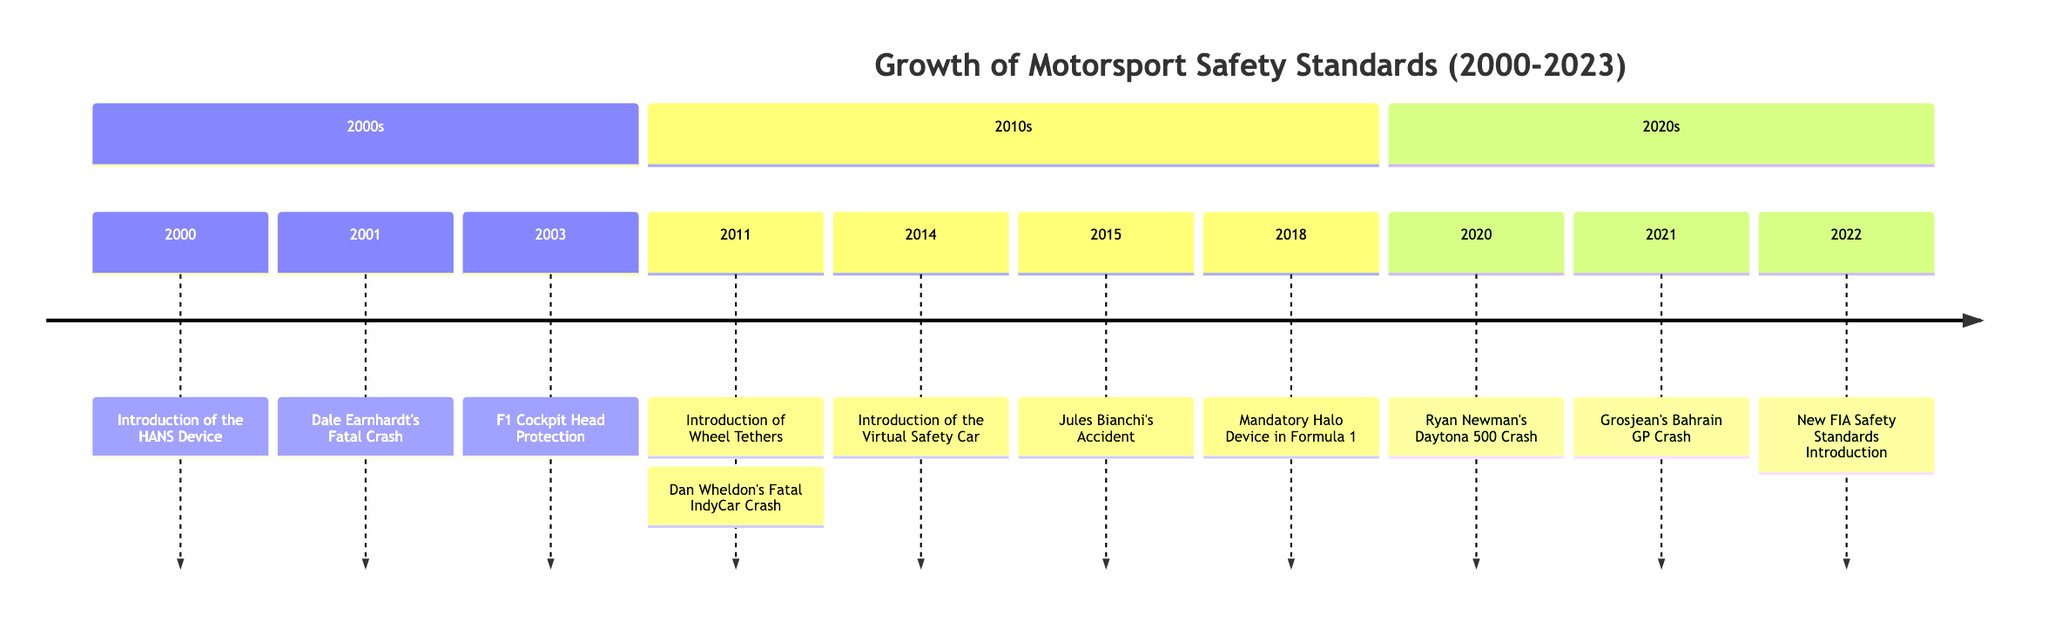What year did the HANS device become mandatory? The HANS device was introduced in 2000, which makes that the year it became mandatory in various motorsport disciplines.
Answer: 2000 How many major incidents are listed in the timeline? By counting the significant incidents mentioned in the timeline, we find six occurrences: Dale Earnhardt's crash in 2001, Dan Wheldon's crash in 2011, Jules Bianchi's accident in 2015, Ryan Newman's crash in 2020, and Grosjean's crash in 2021.
Answer: 6 What safety feature was introduced in Formula 1 in 2018? The Halo device became mandatory in Formula 1 and Formula 2 to enhance head protection for drivers.
Answer: Halo device What significant event influenced the introduction of the Virtual Safety Car? The Virtual Safety Car was introduced in 2014, primarily to improve safety during incidents in response to the need to slow down cars without deploying a physical safety car.
Answer: 2014 Which incident led to changes in IndyCar's safety protocols? Dan Wheldon's fatal crash in 2011 prompted significant changes in IndyCar's safety measures, emphasizing improved cockpit protection.
Answer: Dan Wheldon's Fatal IndyCar Crash What was a major consequence of the Ryan Newman crash in 2020? Ryan Newman's crash highlighted the effectiveness of existing safety enhancements and led to further improvements in NASCAR's safety measures.
Answer: Further safety improvements In which year did Formula 1 implement wheel tethers? Formula 1 made wheel tethers mandatory in 2011 as a safety measure to prevent wheels from detaching during crashes.
Answer: 2011 What was a key advancement after Jules Bianchi's accident? Following Jules Bianchi's accident, Formula 1 introduced enhancements to the Safety Car protocols and promoted the development of the Halo device.
Answer: Halo device development Which year saw the introduction of new FIA safety standards? The new FIA safety standards were introduced in 2022, focusing on various aspects of safety across multiple racing categories.
Answer: 2022 